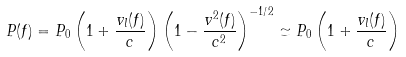<formula> <loc_0><loc_0><loc_500><loc_500>P ( f ) = P _ { 0 } \left ( 1 + \frac { v _ { l } ( f ) } { c } \right ) \left ( 1 - \frac { v ^ { 2 } ( f ) } { c ^ { 2 } } \right ) ^ { - 1 / 2 } \simeq P _ { 0 } \left ( 1 + \frac { v _ { l } ( f ) } { c } \right )</formula> 